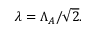Convert formula to latex. <formula><loc_0><loc_0><loc_500><loc_500>\lambda = \Lambda _ { A } / \sqrt { 2 } .</formula> 